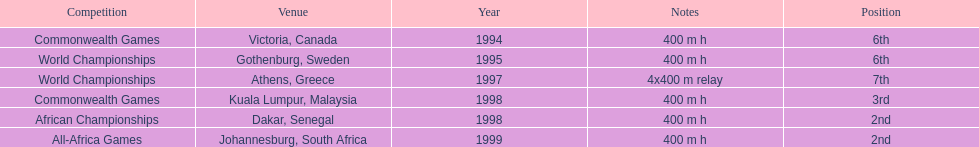In which years did ken harnden achieve a higher position than 5th place? 1998, 1999. 